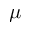Convert formula to latex. <formula><loc_0><loc_0><loc_500><loc_500>\mu</formula> 